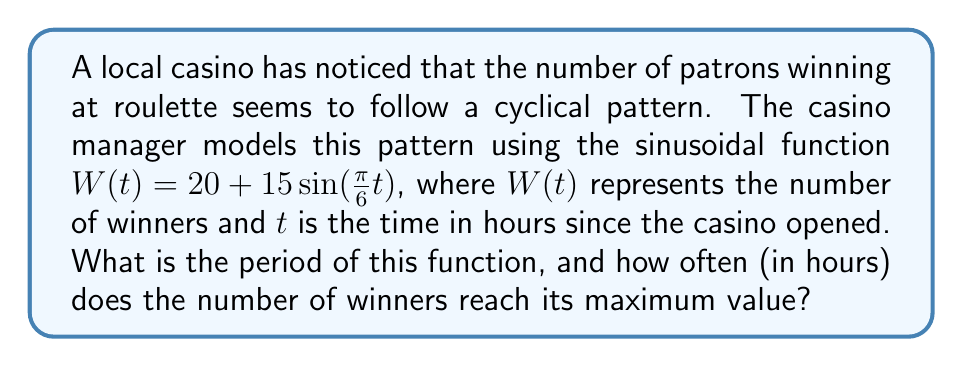Can you answer this question? To solve this problem, we need to analyze the given sinusoidal function:

$W(t) = 20 + 15\sin(\frac{\pi}{6}t)$

1. The general form of a sinusoidal function is:
   $f(t) = A\sin(Bt) + C$
   where $B = \frac{2\pi}{P}$, and $P$ is the period.

2. In our function, $B = \frac{\pi}{6}$

3. To find the period, we use the formula:
   $P = \frac{2\pi}{B}$

4. Substituting our $B$ value:
   $P = \frac{2\pi}{\frac{\pi}{6}} = 2\pi \cdot \frac{6}{\pi} = 12$

5. Therefore, the period of the function is 12 hours.

6. The maximum value of a sinusoidal function occurs every full period. Since the period is 12 hours, the number of winners reaches its maximum value every 12 hours.
Answer: Period: 12 hours; Maximum every 12 hours 